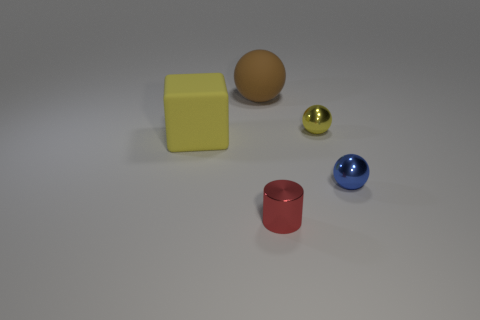There is a sphere that is the same color as the cube; what is its material?
Keep it short and to the point. Metal. What shape is the tiny shiny thing that is the same color as the rubber cube?
Offer a very short reply. Sphere. What number of cylinders are yellow metallic things or yellow rubber objects?
Keep it short and to the point. 0. Are there the same number of tiny metallic cylinders on the left side of the small red cylinder and tiny blue metal things that are left of the small blue sphere?
Offer a very short reply. Yes. There is a yellow shiny thing that is the same shape as the large brown matte object; what is its size?
Give a very brief answer. Small. There is a metal thing that is both right of the red cylinder and in front of the big yellow thing; what size is it?
Make the answer very short. Small. Are there any large rubber things behind the large rubber block?
Offer a terse response. Yes. What number of things are either shiny spheres behind the yellow matte thing or big blocks?
Give a very brief answer. 2. There is a large thing on the right side of the block; how many big yellow rubber things are in front of it?
Ensure brevity in your answer.  1. Is the number of yellow cubes behind the yellow rubber object less than the number of tiny red metal cylinders that are to the right of the big brown thing?
Provide a short and direct response. Yes. 